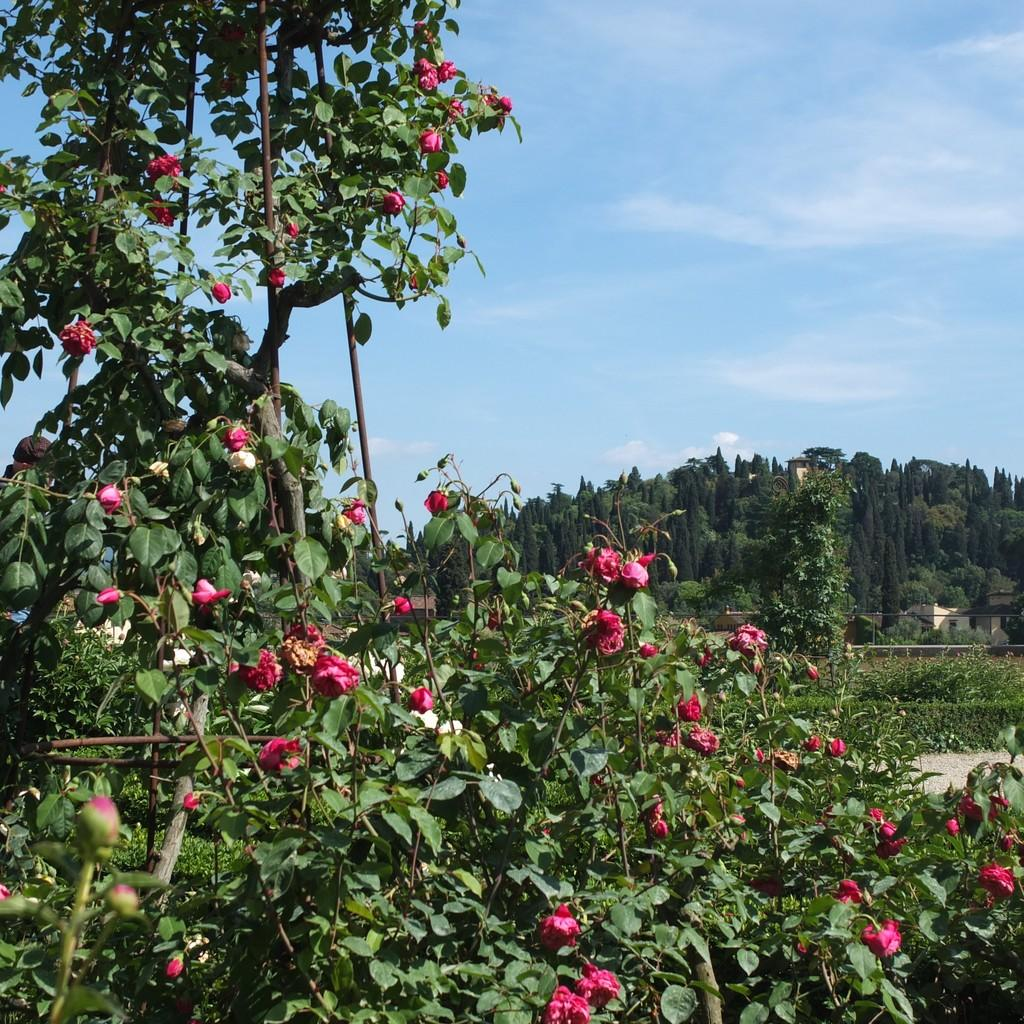What is the main subject in the center of the image? There are plants with flowers in the center of the image. What can be seen in the background of the image? The sky, clouds, trees, and other objects are visible in the background of the image. How many passengers are visible in the image? There are no passengers present in the image. What type of arm is visible in the image? There is no arm visible in the image. 